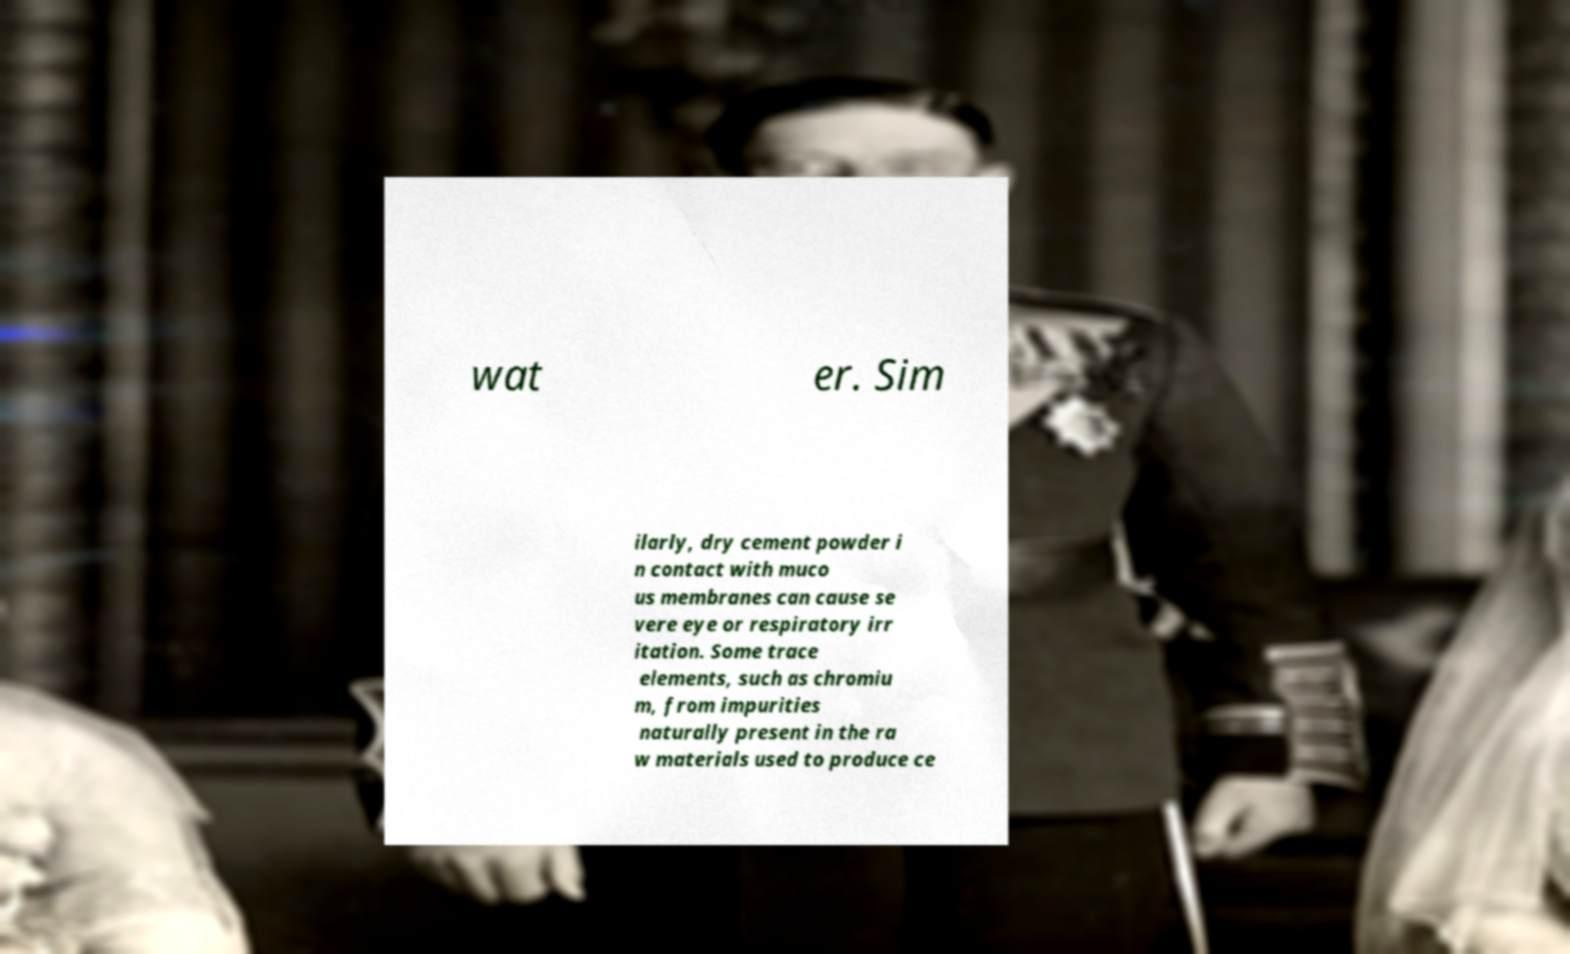Please read and relay the text visible in this image. What does it say? wat er. Sim ilarly, dry cement powder i n contact with muco us membranes can cause se vere eye or respiratory irr itation. Some trace elements, such as chromiu m, from impurities naturally present in the ra w materials used to produce ce 